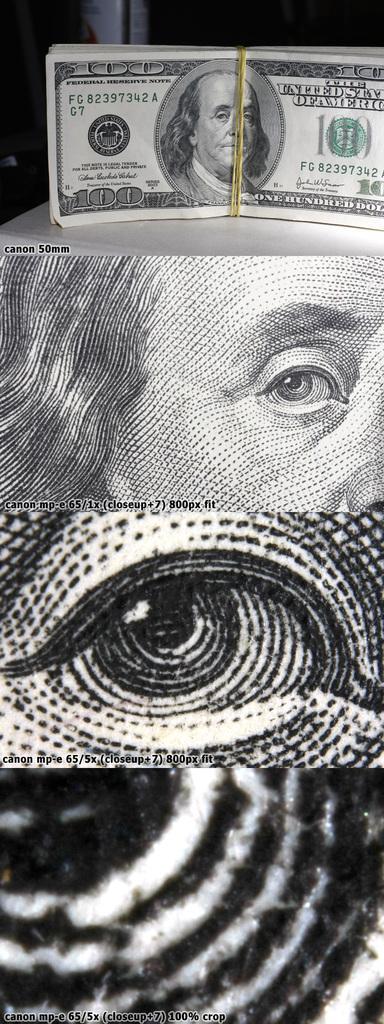Could you give a brief overview of what you see in this image? This is black and white an edited picture, in which we see Benjamin Franklin on a 100 dollar note. In the remaining picture, we see eye of his. 